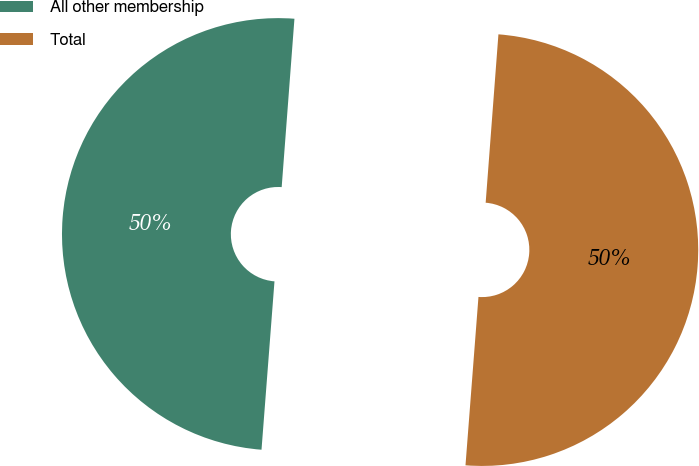Convert chart. <chart><loc_0><loc_0><loc_500><loc_500><pie_chart><fcel>All other membership<fcel>Total<nl><fcel>49.98%<fcel>50.02%<nl></chart> 